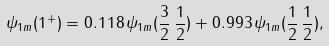<formula> <loc_0><loc_0><loc_500><loc_500>\psi _ { 1 m } ( 1 ^ { + } ) = 0 . 1 1 8 \, \psi _ { 1 m } ( \frac { 3 } { 2 } \, \frac { 1 } { 2 } ) + 0 . 9 9 3 \, \psi _ { 1 m } ( \frac { 1 } { 2 } \, \frac { 1 } { 2 } ) ,</formula> 